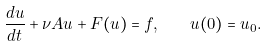Convert formula to latex. <formula><loc_0><loc_0><loc_500><loc_500>\frac { d u } { d t } + \nu A u + F ( u ) = f , \quad u ( 0 ) = u _ { 0 } .</formula> 